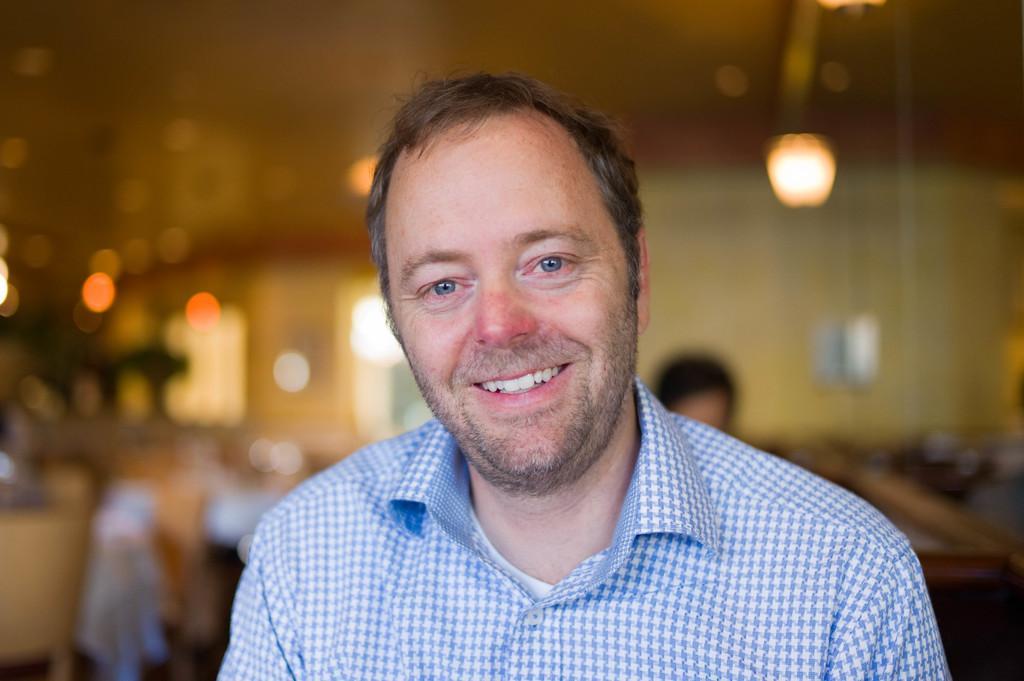How would you summarize this image in a sentence or two? We can see a man is smiling. In the background the image is blur but we can see lights,wall,a person head and other objects. 